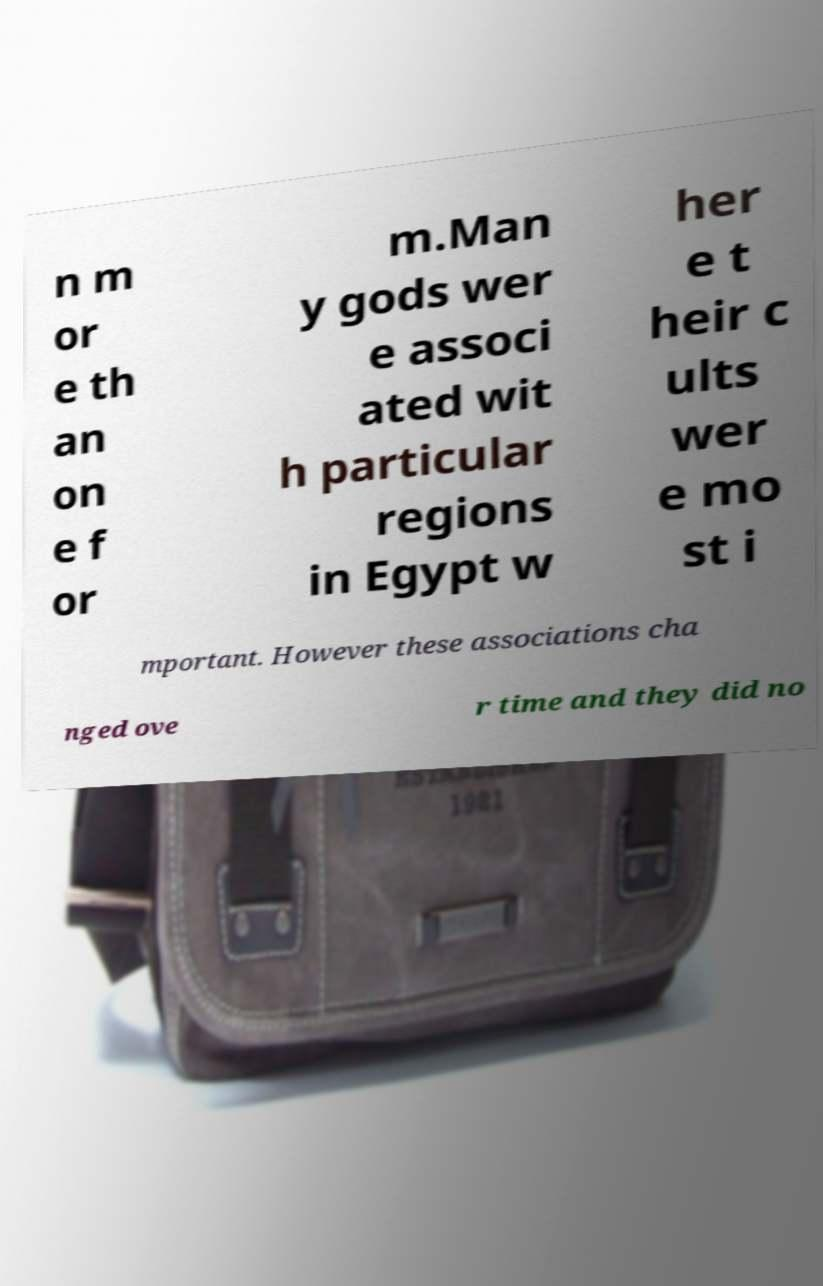I need the written content from this picture converted into text. Can you do that? n m or e th an on e f or m.Man y gods wer e associ ated wit h particular regions in Egypt w her e t heir c ults wer e mo st i mportant. However these associations cha nged ove r time and they did no 